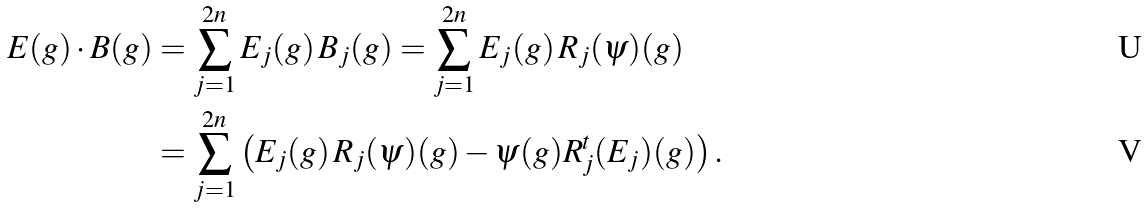<formula> <loc_0><loc_0><loc_500><loc_500>E ( g ) \cdot B ( g ) & = \sum _ { j = 1 } ^ { 2 n } E _ { j } ( g ) \, B _ { j } ( g ) = \sum _ { j = 1 } ^ { 2 n } E _ { j } ( g ) \, R _ { j } ( \psi ) ( g ) \\ & = \sum _ { j = 1 } ^ { 2 n } \left ( E _ { j } ( g ) \, R _ { j } ( \psi ) ( g ) - \psi ( g ) R _ { j } ^ { t } ( E _ { j } ) ( g ) \right ) .</formula> 